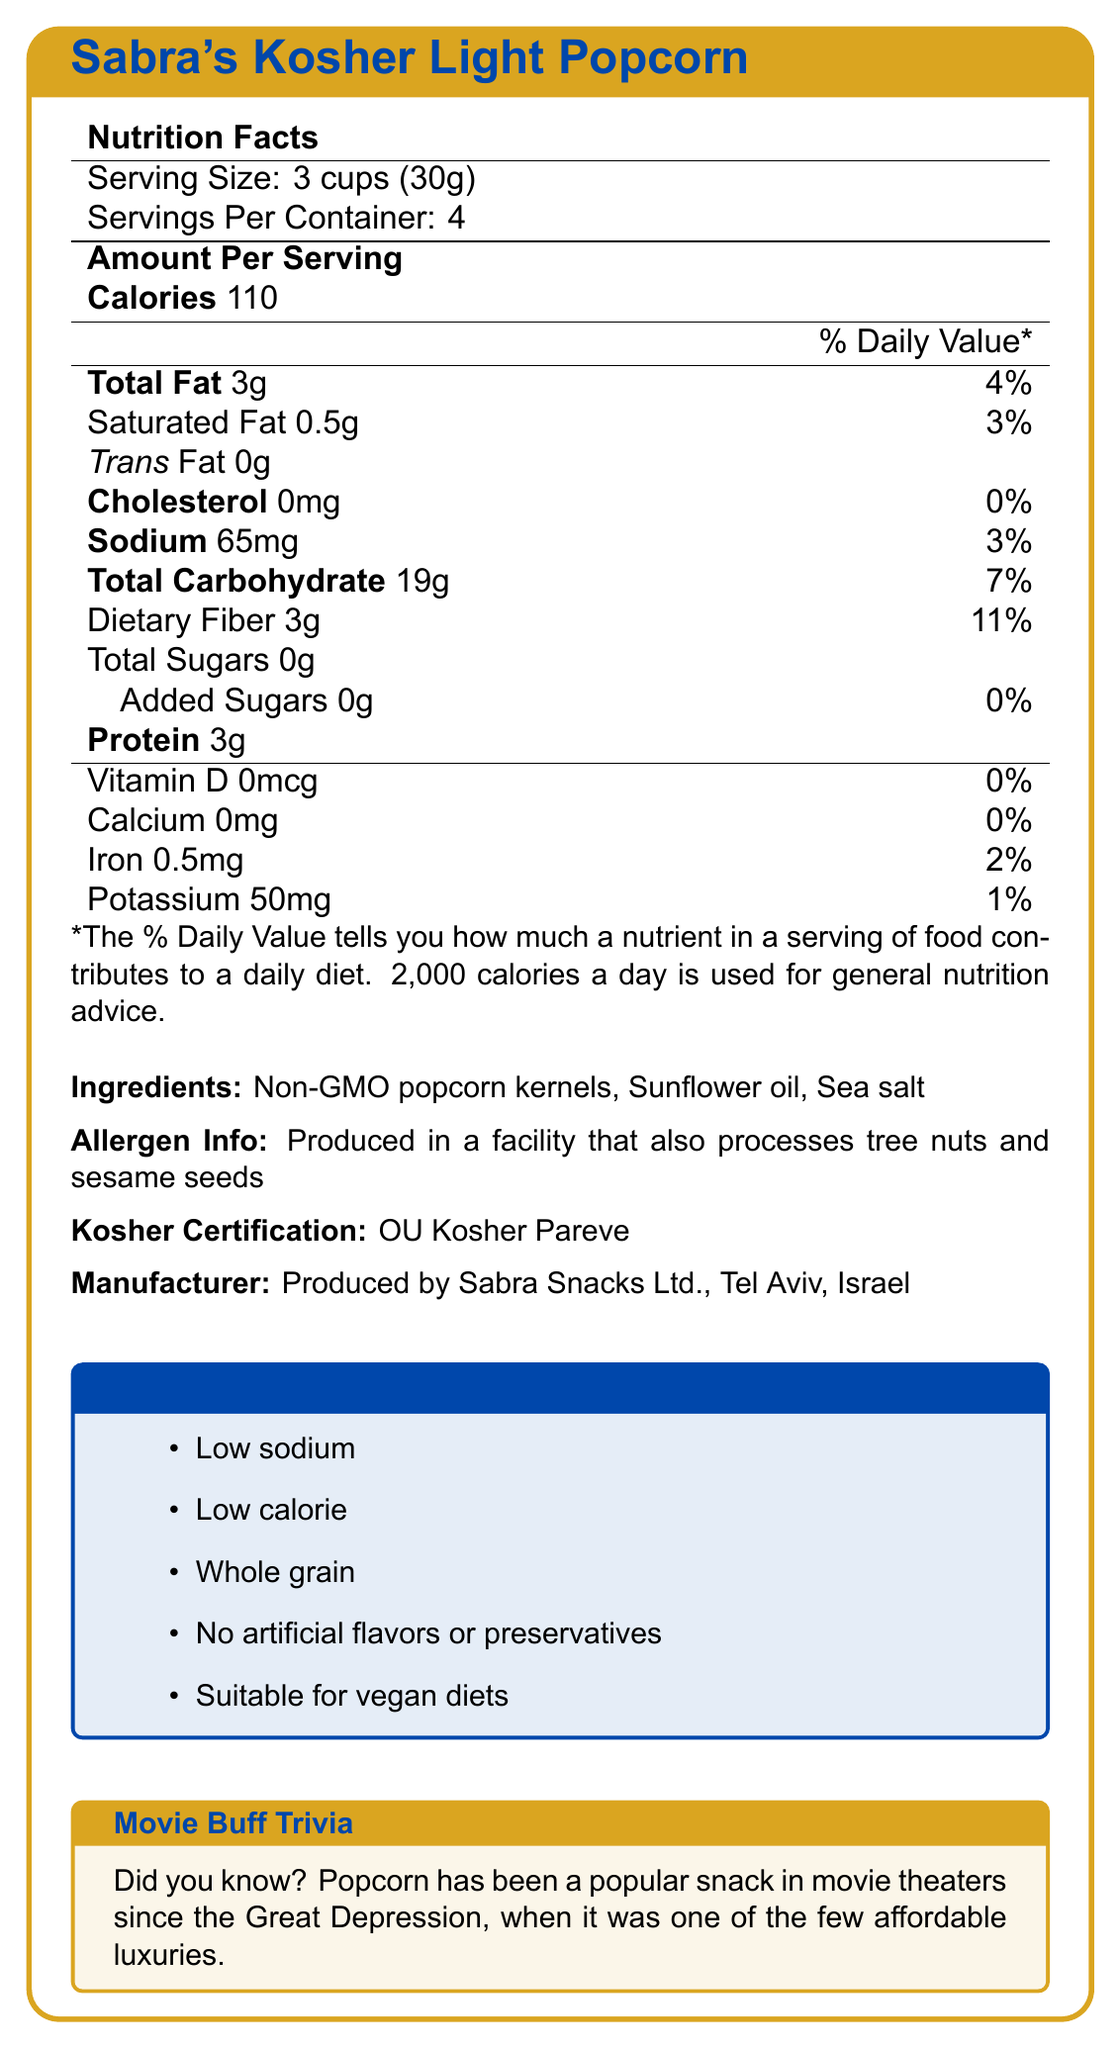what is the serving size of Sabra's Kosher Light Popcorn? The serving size is listed as "3 cups (30g)" in the Nutrition Facts section.
Answer: 3 cups (30g) how many calories are there in one serving of the popcorn? The document states that there are 110 calories per serving in the Nutrition Facts section.
Answer: 110 calories how much sodium is in each serving of the popcorn? The amount of sodium per serving is listed as 65mg in the Nutrition Facts section.
Answer: 65mg what is the kosher certification for the popcorn? The document states that the product is OU Kosher Pareve certified in the Kosher Certification section.
Answer: OU Kosher Pareve what allergens are processed in the facility that makes the popcorn? The Allergen Info section mentions that the facility also processes tree nuts and sesame seeds.
Answer: Tree nuts and sesame seeds which of the following is NOT an ingredient in Sabra's Kosher Light Popcorn? A. Non-GMO popcorn kernels B. Corn oil C. Sea salt D. Sunflower oil The ingredients listed are Non-GMO popcorn kernels, Sunflower oil, and Sea salt. Corn oil is not listed as an ingredient.
Answer: B. Corn oil what is the daily recommended amount of sodium that this popcorn contributes to? A. 1% B. 3% C. 5% D. 10% The Nutrition Facts section shows that the sodium content is 65mg, which is 3% of the Daily Value.
Answer: B. 3% is the popcorn suitable for vegan diets? The Special Features section states that the product is suitable for vegan diets.
Answer: Yes does the popcorn contain any artificial flavors or preservatives? The Special Features section explicitly states that the popcorn has no artificial flavors or preservatives.
Answer: No summarize the main features of Sabra's Kosher Light Popcorn. The document provides detailed information about the nutritional content, ingredients, allergen information, and special features of the popcorn, emphasizing its kosher certification, low calorie and sodium content, and suitability for vegan diets.
Answer: Sabra's Kosher Light Popcorn is a kosher-certified, low-calorie, and low-sodium snack. It is made from Non-GMO popcorn kernels, sunflower oil, and sea salt, and it contains no artificial flavors or preservatives. The popcorn is also suitable for vegan diets and is a good source of fiber. Each serving size is 3 cups (30g) with 110 calories and 65mg of sodium. how many servings are there in one container of Sabra's Kosher Light Popcorn? The Servings Per Container section states that there are 4 servings per container.
Answer: 4 servings does Sabra's Kosher Light Popcorn contain any cholesterol? The document lists the cholesterol content as 0mg per serving.
Answer: No how much potassium is in each serving? The Nutrition Facts section lists the potassium content as 50mg per serving.
Answer: 50mg what is the total fat content per serving? The Nutrition Facts section lists the total fat content per serving as 3g.
Answer: 3g does the popcorn contain dietary fiber? The Nutrition Facts section shows that each serving contains 3g of dietary fiber.
Answer: Yes where is the popcorn manufactured? A. Jerusalem, Israel B. Haifa, Israel C. Tel Aviv, Israel D. Eilat, Israel The Manufacturer section states that the product is produced by Sabra Snacks Ltd. in Tel Aviv, Israel.
Answer: C. Tel Aviv, Israel what is the source of the trivia fact mentioned in the document? The Movie Buff Trivia section mentions that popcorn became popular in movie theaters during the Great Depression.
Answer: The Great Depression how much iron is in each serving of the popcorn? The Nutrition Facts section lists the iron content as 0.5mg per serving.
Answer: 0.5mg please list the preparation instructions for the popcorn. The preparation instructions state that the popcorn is ready to eat and should be consumed within 3 days of opening for best taste.
Answer: Ready to eat. For best taste, consume within 3 days of opening. what kind of oil is used in the popcorn? The Ingredients section lists sunflower oil as one of the ingredients.
Answer: Sunflower oil is Sabra's Kosher Light Popcorn branded as a whole grain product? The Special Features section states that the popcorn is a whole grain product.
Answer: Yes how many grams of added sugars are in each serving? The Nutrition Facts section shows that the popcorn contains 0g of added sugars per serving.
Answer: 0g does the document provide the percentage of daily value for total carbohydrates? The document provides that the total carbohydrate content is 19g, which is 7% of the Daily Value.
Answer: Yes 